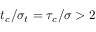<formula> <loc_0><loc_0><loc_500><loc_500>t _ { c } / \sigma _ { t } = \tau _ { c } / \sigma > 2</formula> 